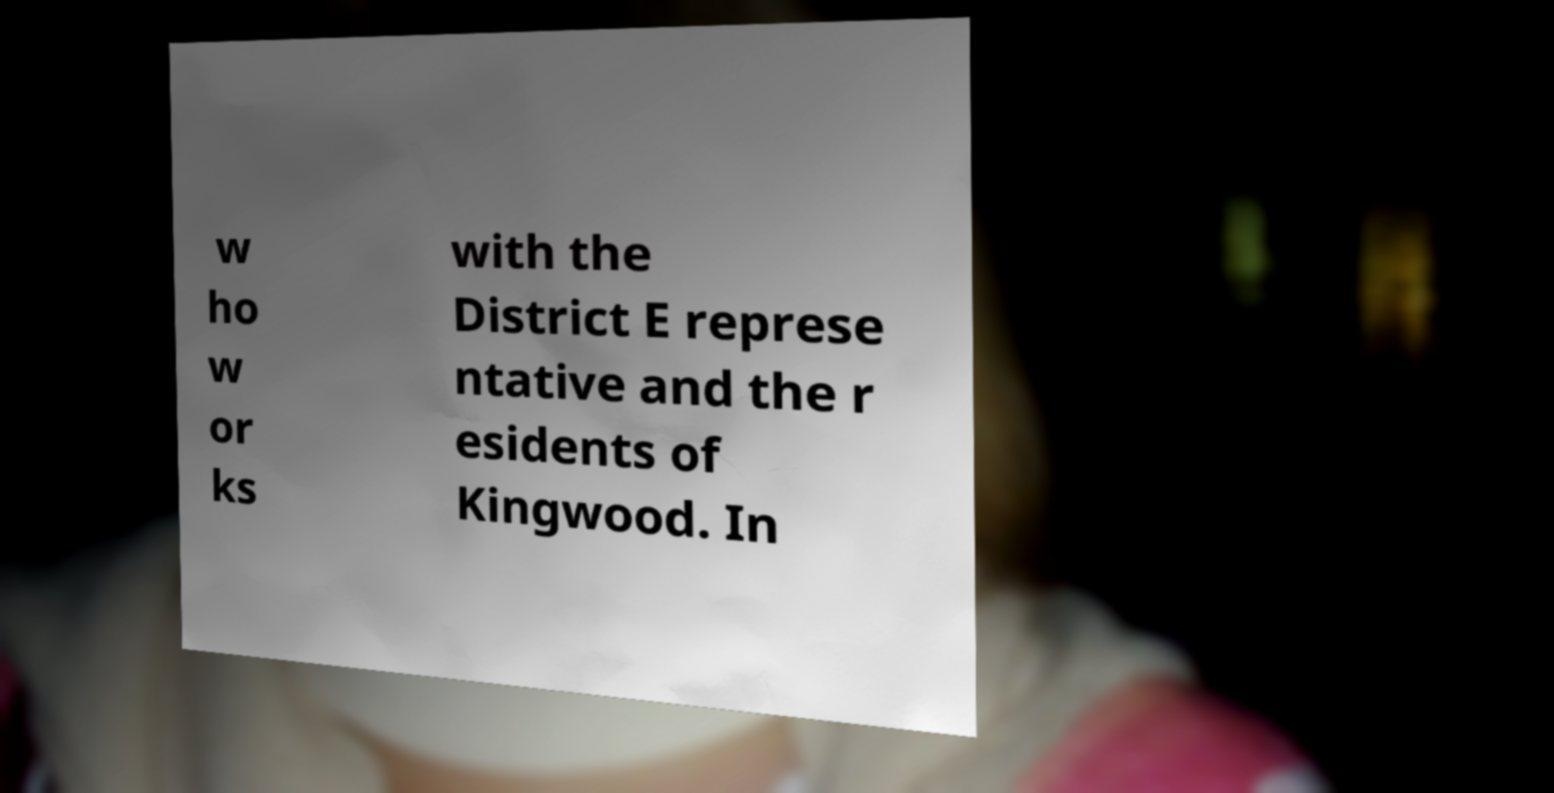Could you extract and type out the text from this image? w ho w or ks with the District E represe ntative and the r esidents of Kingwood. In 